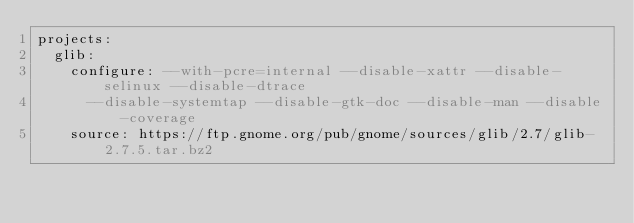<code> <loc_0><loc_0><loc_500><loc_500><_YAML_>projects:
  glib:
    configure: --with-pcre=internal --disable-xattr --disable-selinux --disable-dtrace
      --disable-systemtap --disable-gtk-doc --disable-man --disable-coverage
    source: https://ftp.gnome.org/pub/gnome/sources/glib/2.7/glib-2.7.5.tar.bz2
</code> 